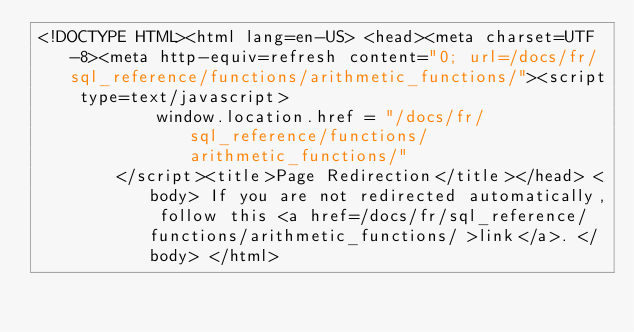<code> <loc_0><loc_0><loc_500><loc_500><_HTML_><!DOCTYPE HTML><html lang=en-US> <head><meta charset=UTF-8><meta http-equiv=refresh content="0; url=/docs/fr/sql_reference/functions/arithmetic_functions/"><script type=text/javascript>
            window.location.href = "/docs/fr/sql_reference/functions/arithmetic_functions/"
        </script><title>Page Redirection</title></head> <body> If you are not redirected automatically, follow this <a href=/docs/fr/sql_reference/functions/arithmetic_functions/ >link</a>. </body> </html></code> 